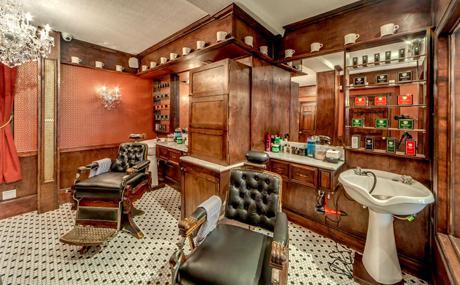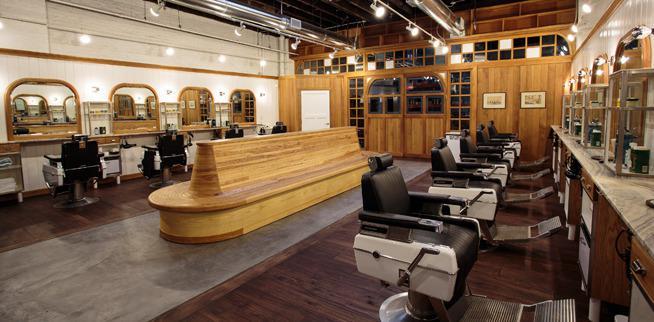The first image is the image on the left, the second image is the image on the right. For the images shown, is this caption "In at least one image there is a single man posing in the middle of a barber shop." true? Answer yes or no. No. The first image is the image on the left, the second image is the image on the right. Examine the images to the left and right. Is the description "An image includes a row of empty rightward-facing black barber chairs under a row of lights." accurate? Answer yes or no. Yes. 